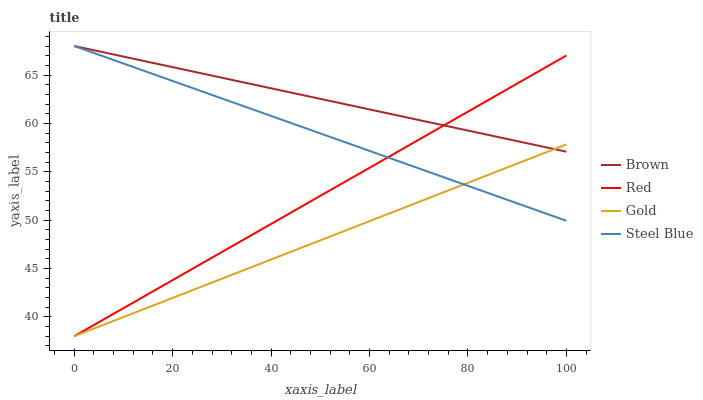Does Gold have the minimum area under the curve?
Answer yes or no. Yes. Does Brown have the maximum area under the curve?
Answer yes or no. Yes. Does Red have the minimum area under the curve?
Answer yes or no. No. Does Red have the maximum area under the curve?
Answer yes or no. No. Is Red the smoothest?
Answer yes or no. Yes. Is Steel Blue the roughest?
Answer yes or no. Yes. Is Gold the smoothest?
Answer yes or no. No. Is Gold the roughest?
Answer yes or no. No. Does Steel Blue have the lowest value?
Answer yes or no. No. Does Steel Blue have the highest value?
Answer yes or no. Yes. Does Red have the highest value?
Answer yes or no. No. Does Red intersect Gold?
Answer yes or no. Yes. Is Red less than Gold?
Answer yes or no. No. Is Red greater than Gold?
Answer yes or no. No. 